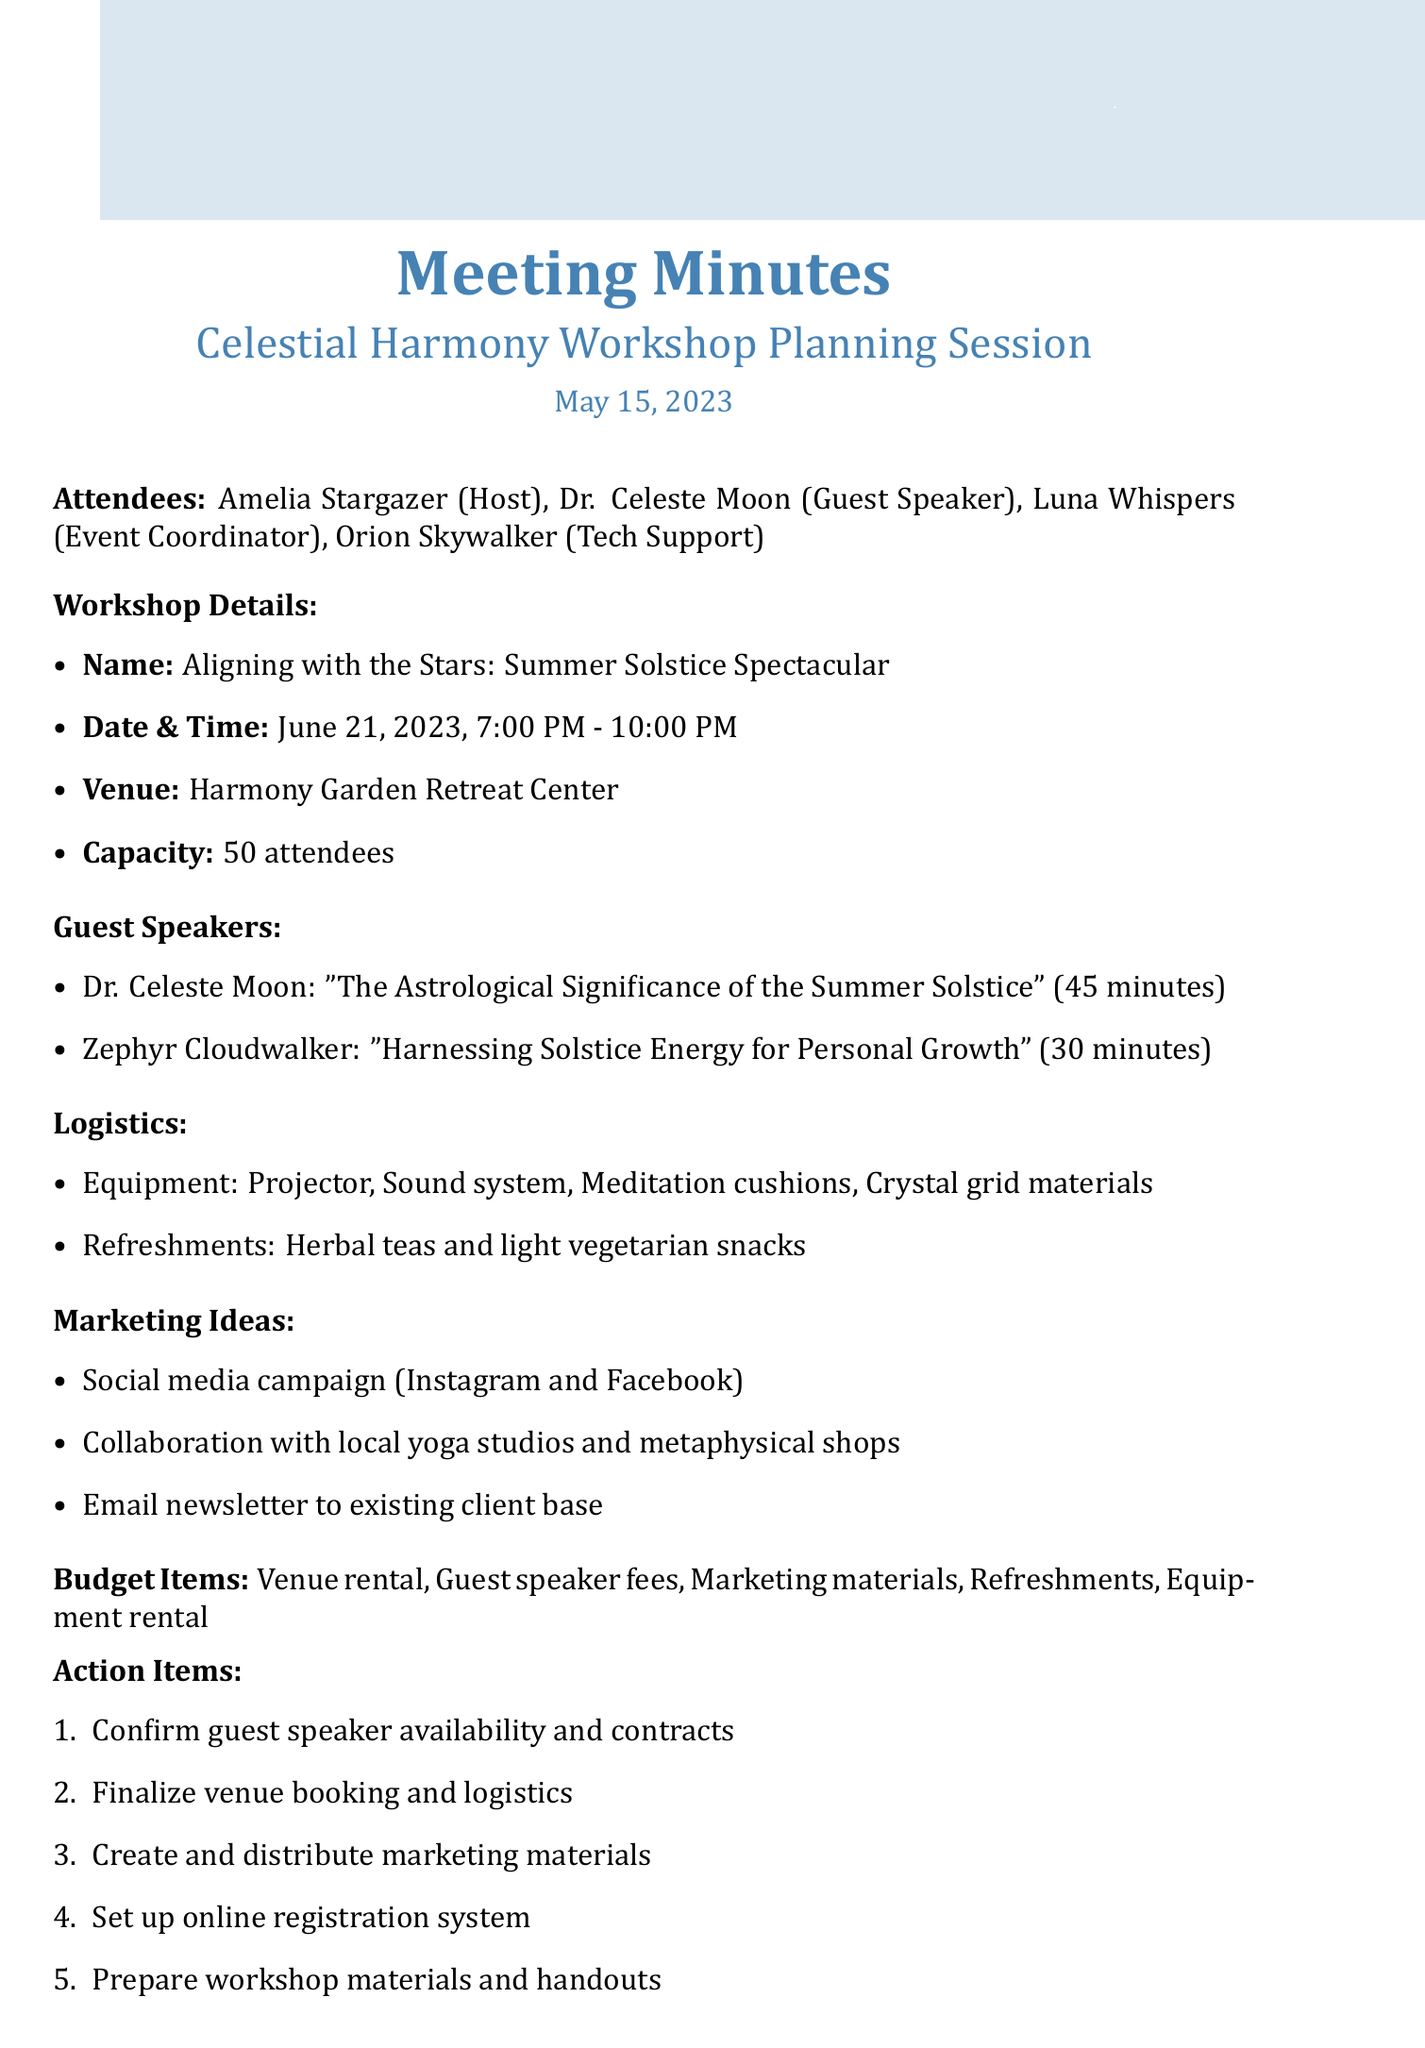What is the date of the workshop? The date of the workshop is clearly stated in the document under workshop details.
Answer: June 21, 2023 Who is the host of the workshop? The host of the workshop is listed among the attendees, providing a clear answer.
Answer: Amelia Stargazer What is the duration of Dr. Celeste Moon's presentation? The duration of Dr. Celeste Moon's presentation is provided in the guest speakers section.
Answer: 45 minutes How many guest speakers are mentioned in the document? The number of guest speakers can be counted from the guest speakers section in the document.
Answer: 2 What type of refreshments will be offered? The refreshments are specified directly in the logistics section.
Answer: Herbal teas and light vegetarian snacks What is one marketing idea proposed for the workshop? Marketing ideas are listed in the document, and one can be selected for the answer.
Answer: Social media campaign focusing on Instagram and Facebook What equipment is needed for the workshop? The needed equipment is enumerated in the logistics section detailing the workshop setup.
Answer: Projector, Sound system, Meditation cushions, Crystal grid materials What is the capacity of the venue? The capacity is clearly stated in the logistics section of the document.
Answer: 50 What is the purpose of the action items? Action items are mentioned at the end of the document, outlining their purpose related to workshop planning.
Answer: To ensure tasks are completed before the workshop 